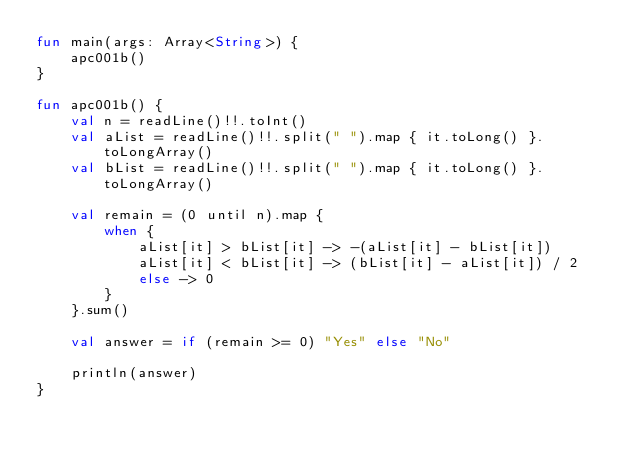<code> <loc_0><loc_0><loc_500><loc_500><_Kotlin_>fun main(args: Array<String>) {
    apc001b()
}

fun apc001b() {
    val n = readLine()!!.toInt()
    val aList = readLine()!!.split(" ").map { it.toLong() }.toLongArray()
    val bList = readLine()!!.split(" ").map { it.toLong() }.toLongArray()

    val remain = (0 until n).map {
        when {
            aList[it] > bList[it] -> -(aList[it] - bList[it])
            aList[it] < bList[it] -> (bList[it] - aList[it]) / 2
            else -> 0
        }
    }.sum()

    val answer = if (remain >= 0) "Yes" else "No"

    println(answer)
}
</code> 